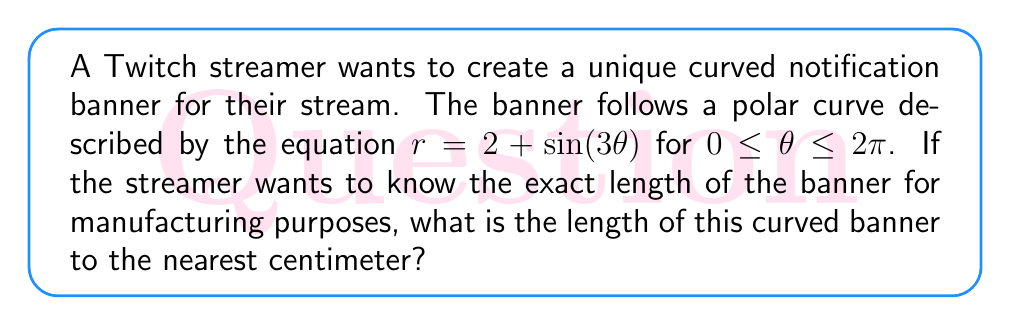Can you answer this question? To find the length of a curve in polar coordinates, we use the arc length formula:

$$L = \int_a^b \sqrt{r^2 + \left(\frac{dr}{d\theta}\right)^2} d\theta$$

Where $r = 2 + \sin(3\theta)$ and $\frac{dr}{d\theta} = 3\cos(3\theta)$

Steps to solve:
1) First, we need to calculate $r^2$ and $\left(\frac{dr}{d\theta}\right)^2$:

   $r^2 = (2 + \sin(3\theta))^2 = 4 + 4\sin(3\theta) + \sin^2(3\theta)$
   $\left(\frac{dr}{d\theta}\right)^2 = (3\cos(3\theta))^2 = 9\cos^2(3\theta)$

2) Now, we substitute these into our integral:

   $$L = \int_0^{2\pi} \sqrt{(4 + 4\sin(3\theta) + \sin^2(3\theta)) + 9\cos^2(3\theta)} d\theta$$

3) Simplify inside the square root:

   $$L = \int_0^{2\pi} \sqrt{4 + 4\sin(3\theta) + \sin^2(3\theta) + 9\cos^2(3\theta)} d\theta$$
   $$L = \int_0^{2\pi} \sqrt{4 + 4\sin(3\theta) + 9 - 8\sin^2(3\theta)} d\theta$$ (using $\sin^2 + \cos^2 = 1$)
   $$L = \int_0^{2\pi} \sqrt{13 + 4\sin(3\theta) - 8\sin^2(3\theta)} d\theta$$

4) This integral cannot be solved analytically. We need to use numerical integration methods to approximate the result.

5) Using a numerical integration tool (like Simpson's rule or a computer algebra system), we get:

   $$L \approx 14.3775$$

6) Rounding to the nearest centimeter:

   $$L \approx 14 \text{ cm}$$
Answer: 14 cm 